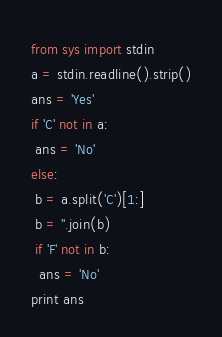<code> <loc_0><loc_0><loc_500><loc_500><_Python_>from sys import stdin
a = stdin.readline().strip()
ans = 'Yes'
if 'C' not in a:
 ans = 'No'
else:
 b = a.split('C')[1:]
 b = ''.join(b)
 if 'F' not in b:
  ans = 'No'
print ans</code> 